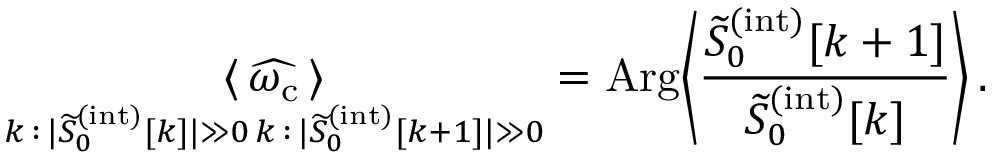<formula> <loc_0><loc_0><loc_500><loc_500>\underset { \substack { k \, \colon \, | \widetilde { S } _ { 0 } ^ { ( i n t ) } [ k ] | \gg 0 \, k \, \colon \, | \widetilde { S } _ { 0 } ^ { ( i n t ) } [ k + 1 ] | \gg 0 } } { \langle \, \widehat { \omega _ { c } } \, \rangle } = A r g \left \langle \frac { \widetilde { S } _ { 0 } ^ { ( i n t ) } [ k + 1 ] } { \widetilde { S } _ { 0 } ^ { ( i n t ) } [ k ] } \right \rangle \, .</formula> 